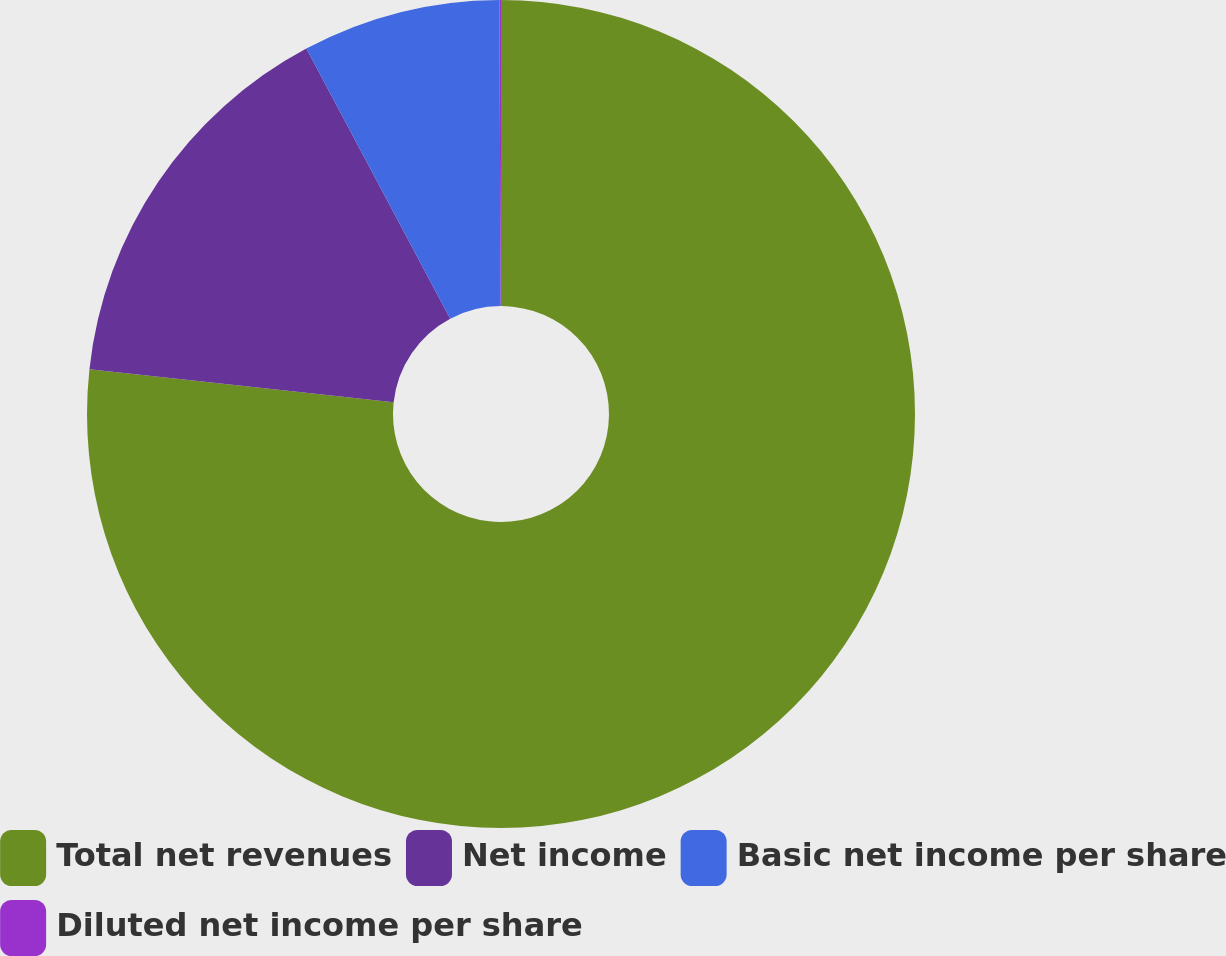Convert chart to OTSL. <chart><loc_0><loc_0><loc_500><loc_500><pie_chart><fcel>Total net revenues<fcel>Net income<fcel>Basic net income per share<fcel>Diluted net income per share<nl><fcel>76.72%<fcel>15.48%<fcel>7.73%<fcel>0.06%<nl></chart> 